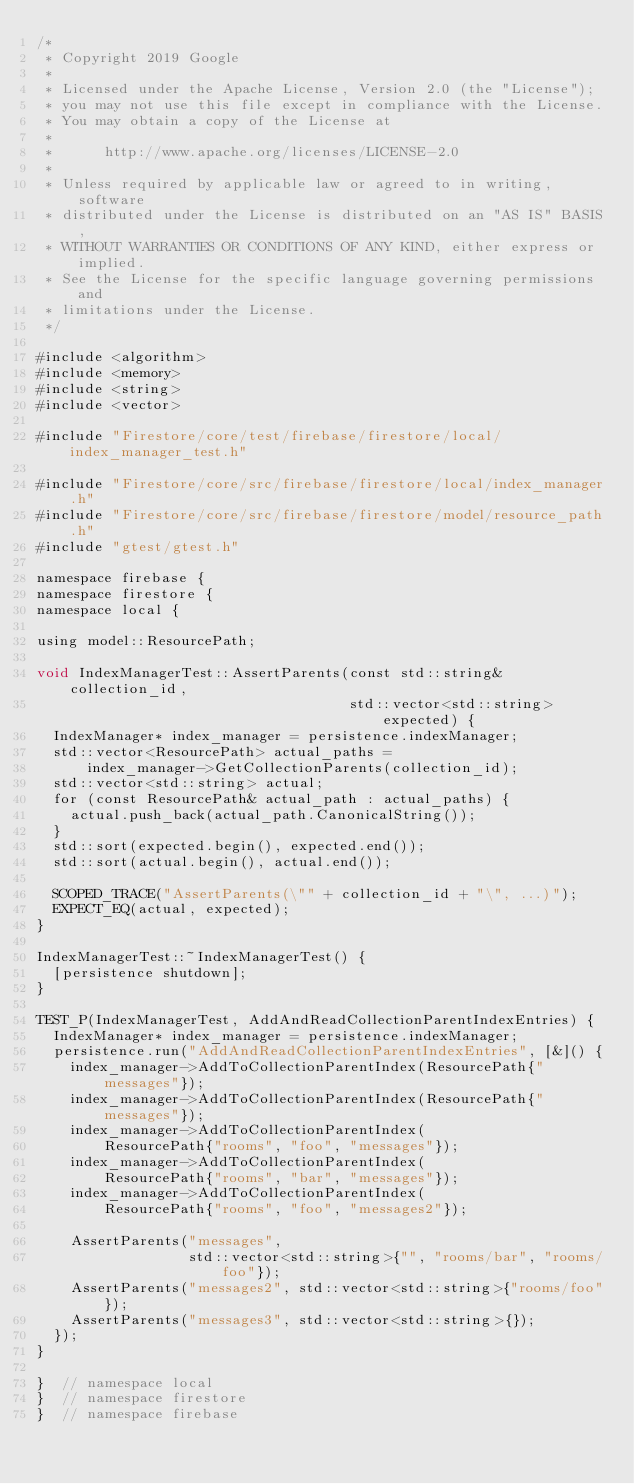<code> <loc_0><loc_0><loc_500><loc_500><_ObjectiveC_>/*
 * Copyright 2019 Google
 *
 * Licensed under the Apache License, Version 2.0 (the "License");
 * you may not use this file except in compliance with the License.
 * You may obtain a copy of the License at
 *
 *      http://www.apache.org/licenses/LICENSE-2.0
 *
 * Unless required by applicable law or agreed to in writing, software
 * distributed under the License is distributed on an "AS IS" BASIS,
 * WITHOUT WARRANTIES OR CONDITIONS OF ANY KIND, either express or implied.
 * See the License for the specific language governing permissions and
 * limitations under the License.
 */

#include <algorithm>
#include <memory>
#include <string>
#include <vector>

#include "Firestore/core/test/firebase/firestore/local/index_manager_test.h"

#include "Firestore/core/src/firebase/firestore/local/index_manager.h"
#include "Firestore/core/src/firebase/firestore/model/resource_path.h"
#include "gtest/gtest.h"

namespace firebase {
namespace firestore {
namespace local {

using model::ResourcePath;

void IndexManagerTest::AssertParents(const std::string& collection_id,
                                     std::vector<std::string> expected) {
  IndexManager* index_manager = persistence.indexManager;
  std::vector<ResourcePath> actual_paths =
      index_manager->GetCollectionParents(collection_id);
  std::vector<std::string> actual;
  for (const ResourcePath& actual_path : actual_paths) {
    actual.push_back(actual_path.CanonicalString());
  }
  std::sort(expected.begin(), expected.end());
  std::sort(actual.begin(), actual.end());

  SCOPED_TRACE("AssertParents(\"" + collection_id + "\", ...)");
  EXPECT_EQ(actual, expected);
}

IndexManagerTest::~IndexManagerTest() {
  [persistence shutdown];
}

TEST_P(IndexManagerTest, AddAndReadCollectionParentIndexEntries) {
  IndexManager* index_manager = persistence.indexManager;
  persistence.run("AddAndReadCollectionParentIndexEntries", [&]() {
    index_manager->AddToCollectionParentIndex(ResourcePath{"messages"});
    index_manager->AddToCollectionParentIndex(ResourcePath{"messages"});
    index_manager->AddToCollectionParentIndex(
        ResourcePath{"rooms", "foo", "messages"});
    index_manager->AddToCollectionParentIndex(
        ResourcePath{"rooms", "bar", "messages"});
    index_manager->AddToCollectionParentIndex(
        ResourcePath{"rooms", "foo", "messages2"});

    AssertParents("messages",
                  std::vector<std::string>{"", "rooms/bar", "rooms/foo"});
    AssertParents("messages2", std::vector<std::string>{"rooms/foo"});
    AssertParents("messages3", std::vector<std::string>{});
  });
}

}  // namespace local
}  // namespace firestore
}  // namespace firebase
</code> 